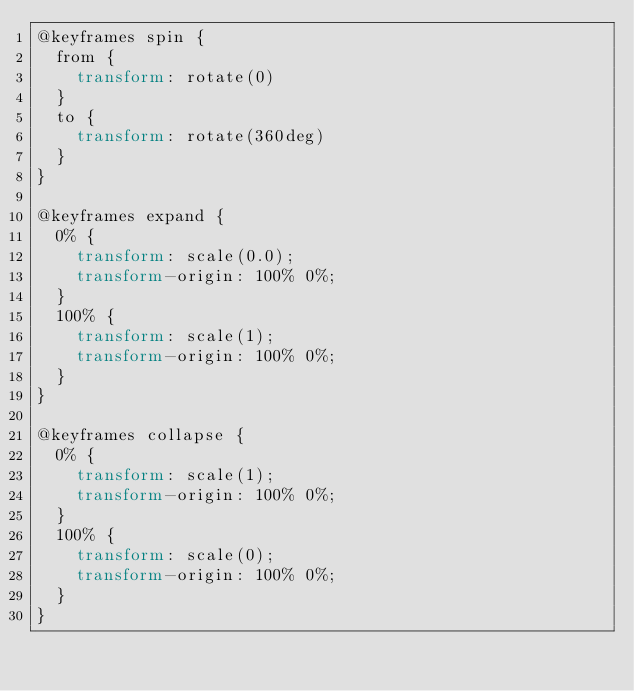<code> <loc_0><loc_0><loc_500><loc_500><_CSS_>@keyframes spin {
  from {
    transform: rotate(0)
  }
  to {
    transform: rotate(360deg)
  }
}

@keyframes expand {
  0% {
    transform: scale(0.0);
    transform-origin: 100% 0%;
  }
  100% {
    transform: scale(1);
    transform-origin: 100% 0%;
  }
}

@keyframes collapse {
  0% {
    transform: scale(1);
    transform-origin: 100% 0%;
  }
  100% {
    transform: scale(0);
    transform-origin: 100% 0%;
  }
}
</code> 